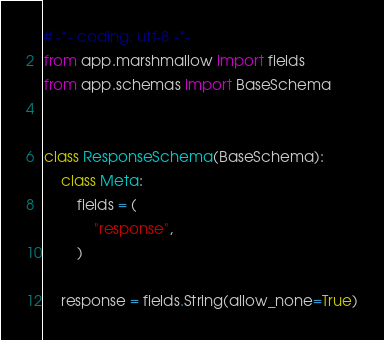Convert code to text. <code><loc_0><loc_0><loc_500><loc_500><_Python_># -*- coding: utf-8 -*-
from app.marshmallow import fields
from app.schemas import BaseSchema


class ResponseSchema(BaseSchema):
    class Meta:
        fields = (
            "response",
        )

    response = fields.String(allow_none=True)
</code> 